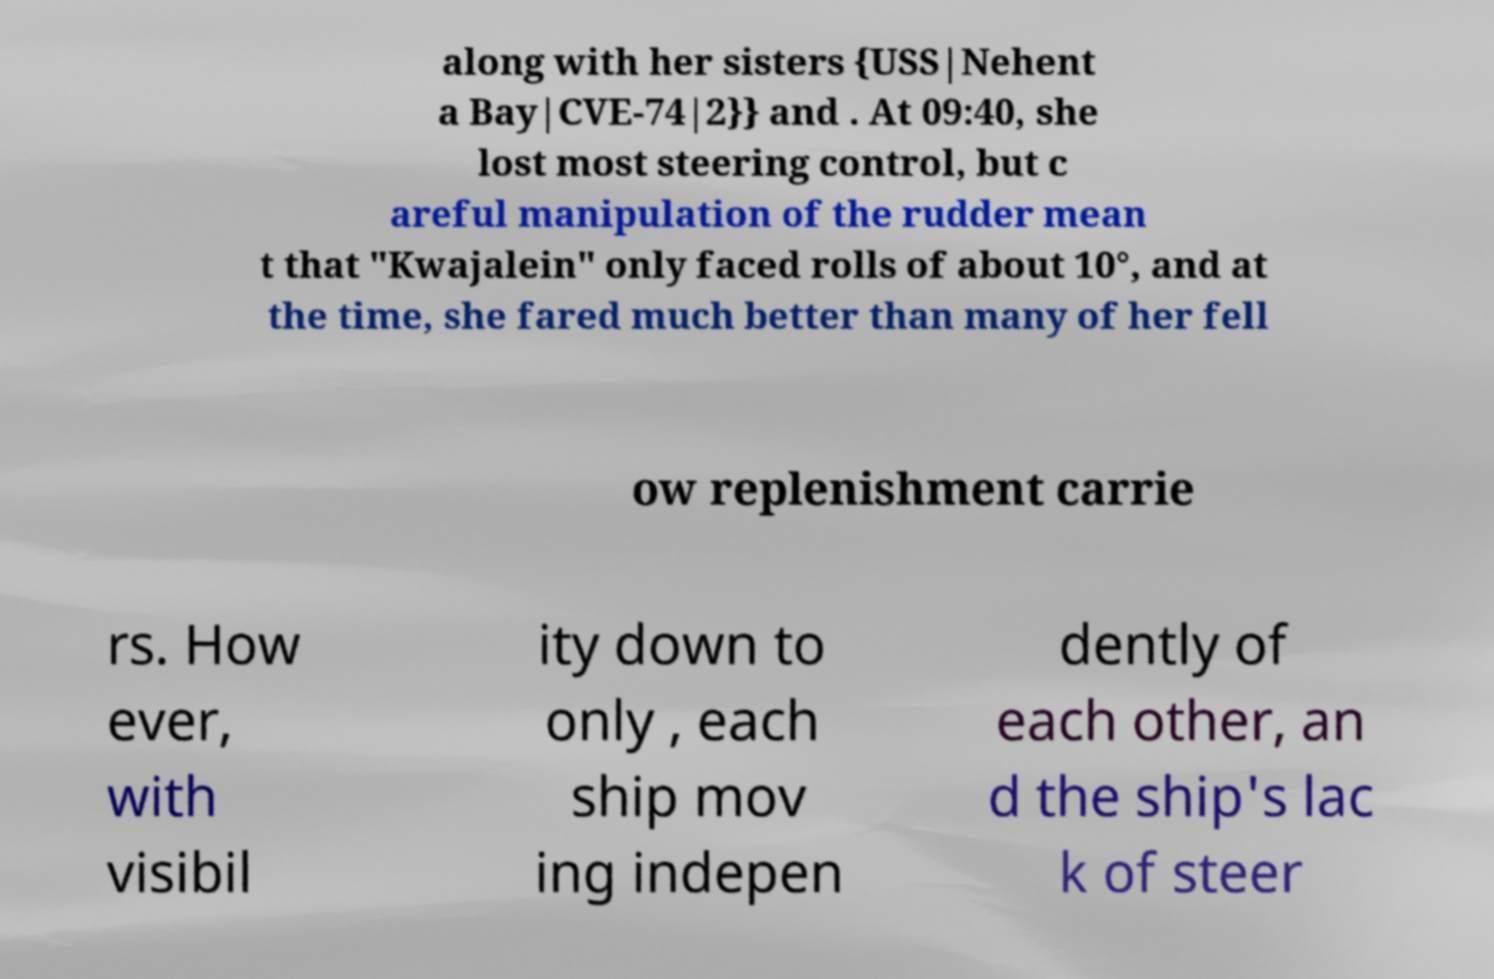For documentation purposes, I need the text within this image transcribed. Could you provide that? along with her sisters {USS|Nehent a Bay|CVE-74|2}} and . At 09:40, she lost most steering control, but c areful manipulation of the rudder mean t that "Kwajalein" only faced rolls of about 10°, and at the time, she fared much better than many of her fell ow replenishment carrie rs. How ever, with visibil ity down to only , each ship mov ing indepen dently of each other, an d the ship's lac k of steer 